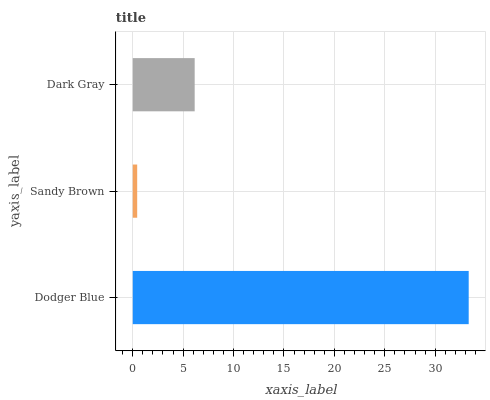Is Sandy Brown the minimum?
Answer yes or no. Yes. Is Dodger Blue the maximum?
Answer yes or no. Yes. Is Dark Gray the minimum?
Answer yes or no. No. Is Dark Gray the maximum?
Answer yes or no. No. Is Dark Gray greater than Sandy Brown?
Answer yes or no. Yes. Is Sandy Brown less than Dark Gray?
Answer yes or no. Yes. Is Sandy Brown greater than Dark Gray?
Answer yes or no. No. Is Dark Gray less than Sandy Brown?
Answer yes or no. No. Is Dark Gray the high median?
Answer yes or no. Yes. Is Dark Gray the low median?
Answer yes or no. Yes. Is Sandy Brown the high median?
Answer yes or no. No. Is Sandy Brown the low median?
Answer yes or no. No. 